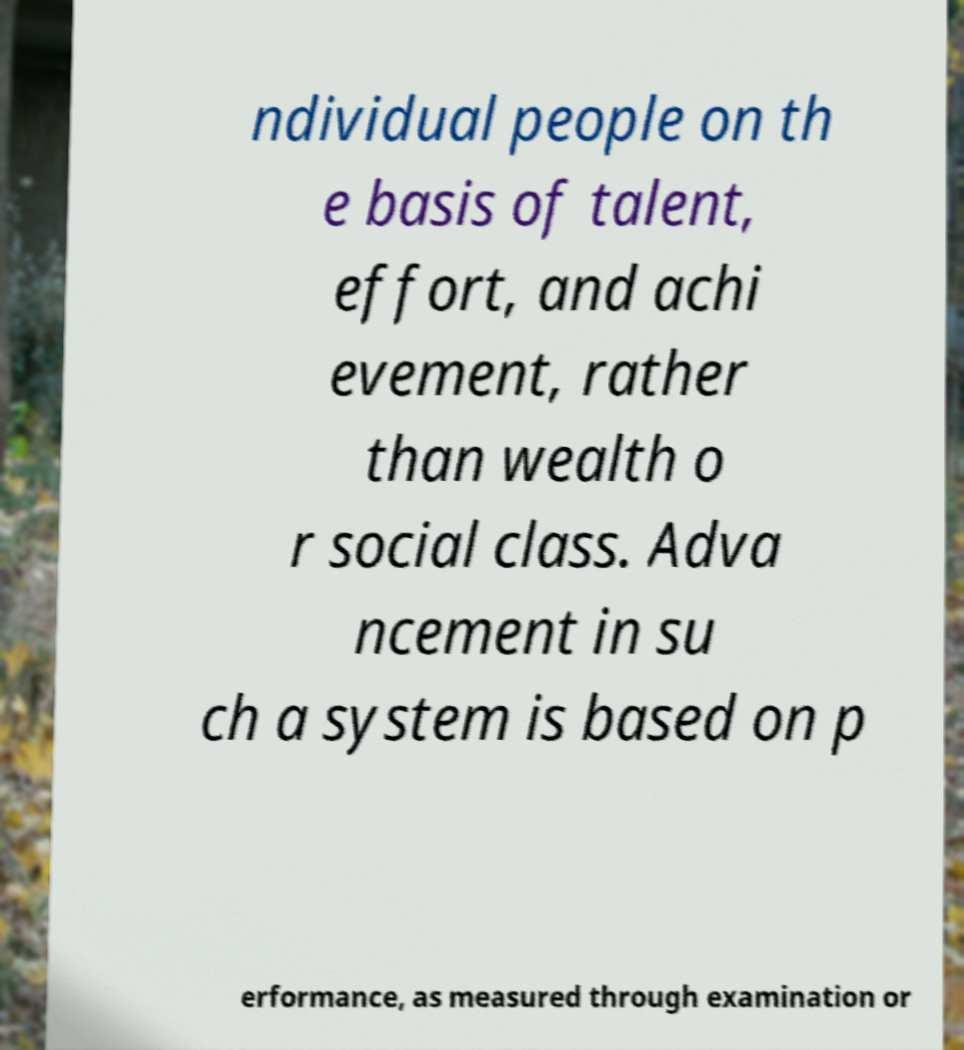For documentation purposes, I need the text within this image transcribed. Could you provide that? ndividual people on th e basis of talent, effort, and achi evement, rather than wealth o r social class. Adva ncement in su ch a system is based on p erformance, as measured through examination or 